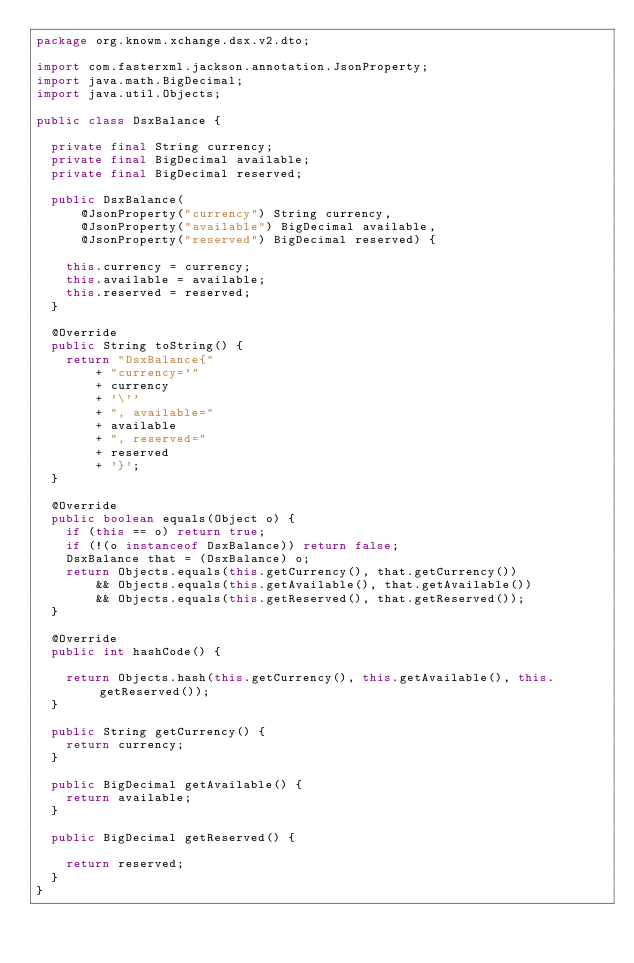<code> <loc_0><loc_0><loc_500><loc_500><_Java_>package org.knowm.xchange.dsx.v2.dto;

import com.fasterxml.jackson.annotation.JsonProperty;
import java.math.BigDecimal;
import java.util.Objects;

public class DsxBalance {

  private final String currency;
  private final BigDecimal available;
  private final BigDecimal reserved;

  public DsxBalance(
      @JsonProperty("currency") String currency,
      @JsonProperty("available") BigDecimal available,
      @JsonProperty("reserved") BigDecimal reserved) {

    this.currency = currency;
    this.available = available;
    this.reserved = reserved;
  }

  @Override
  public String toString() {
    return "DsxBalance{"
        + "currency='"
        + currency
        + '\''
        + ", available="
        + available
        + ", reserved="
        + reserved
        + '}';
  }

  @Override
  public boolean equals(Object o) {
    if (this == o) return true;
    if (!(o instanceof DsxBalance)) return false;
    DsxBalance that = (DsxBalance) o;
    return Objects.equals(this.getCurrency(), that.getCurrency())
        && Objects.equals(this.getAvailable(), that.getAvailable())
        && Objects.equals(this.getReserved(), that.getReserved());
  }

  @Override
  public int hashCode() {

    return Objects.hash(this.getCurrency(), this.getAvailable(), this.getReserved());
  }

  public String getCurrency() {
    return currency;
  }

  public BigDecimal getAvailable() {
    return available;
  }

  public BigDecimal getReserved() {

    return reserved;
  }
}
</code> 